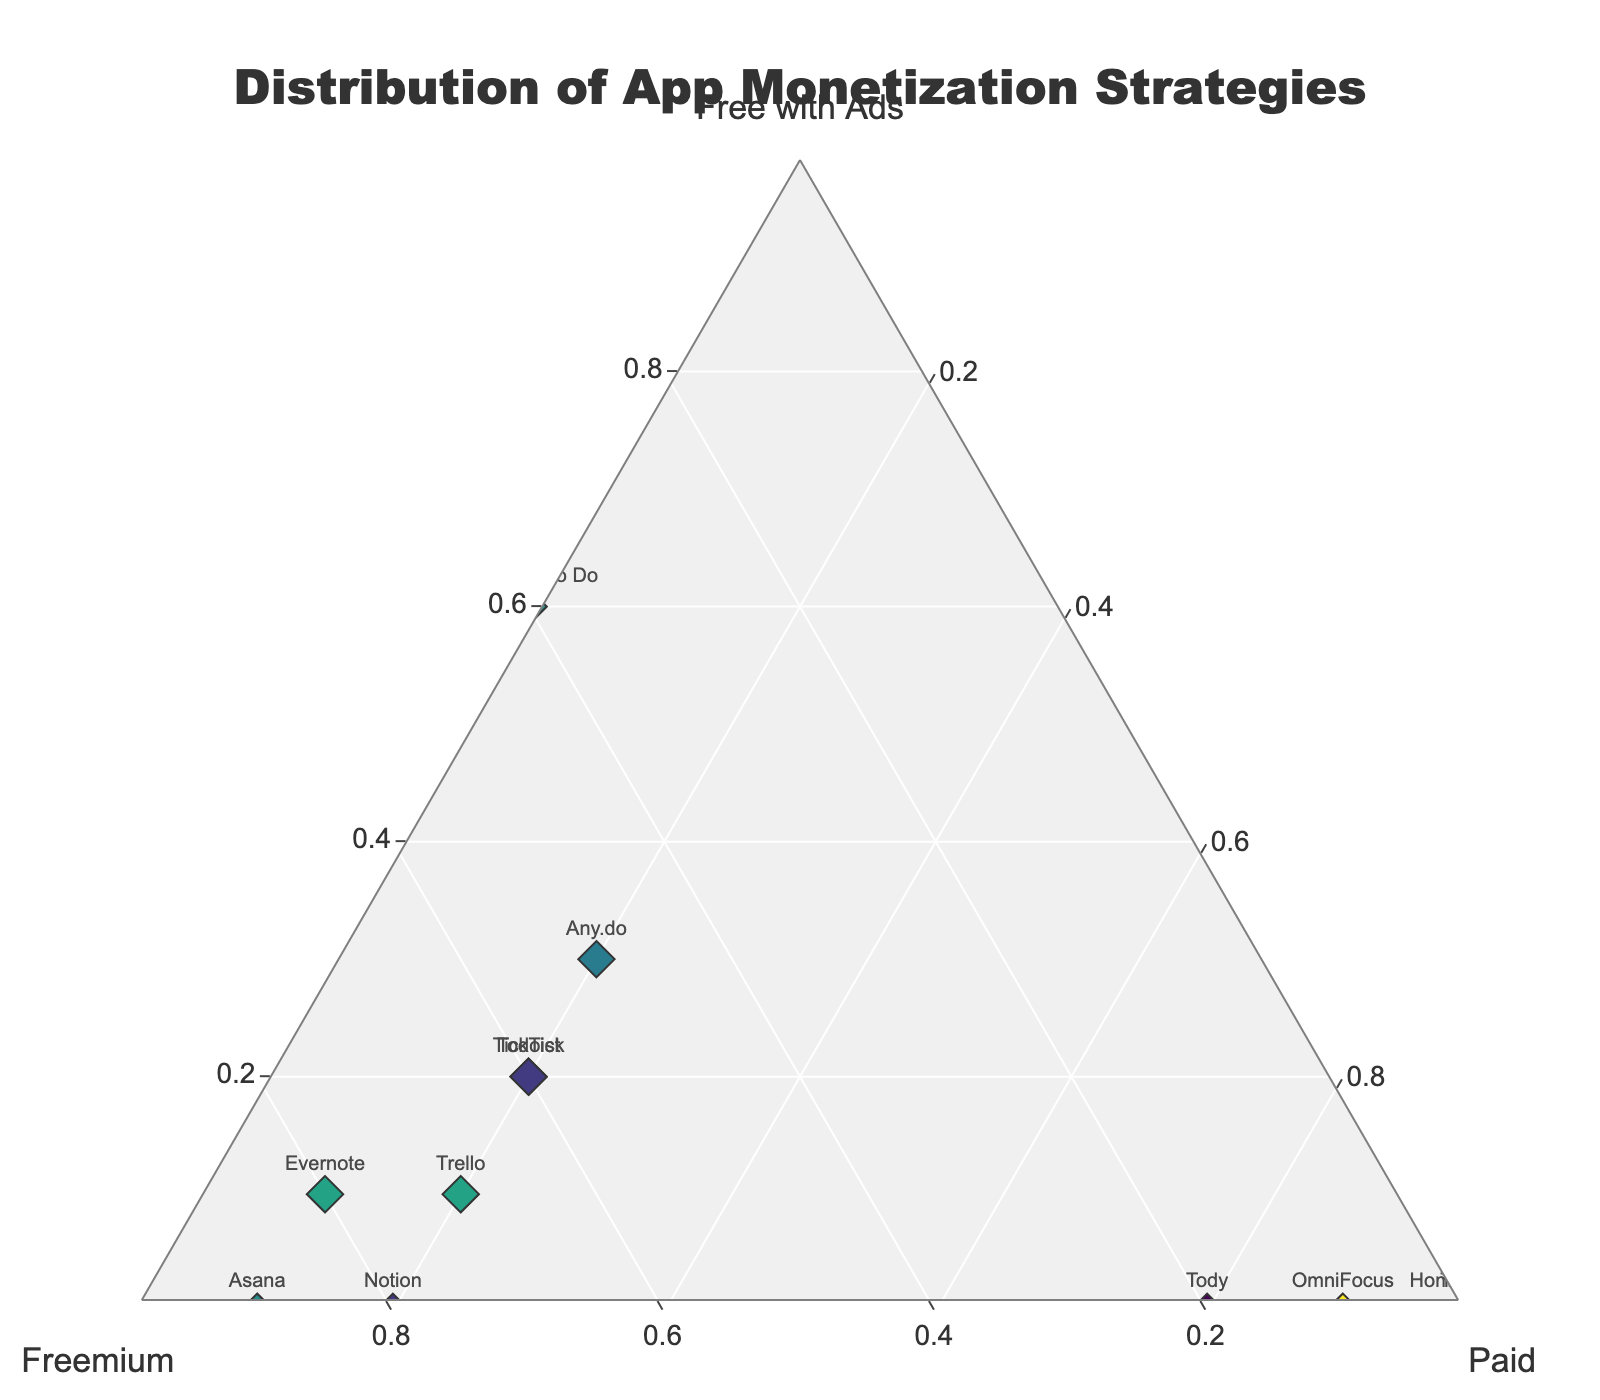What app has the highest percentage of 'Freemium' monetization strategy? Look at the position of each app on the ternary plot. The app that is positioned closest to the 'Freemium' vertex has the highest percentage in that category.
Answer: Asana How many apps use the 'Paid' monetization strategy exclusively? Identify the apps that are positioned exactly along the 'Paid' axis, indicating a 100% use of the 'Paid' strategy.
Answer: Three Which app is positioned exactly at the 'Free with Ads' vertex? Find the app that is positioned at the vertex of the 'Free with Ads' axis, indicating a 100% use of this strategy.
Answer: Google Keep Compare the 'Free with Ads' percentage of Evernote and Microsoft To Do. Which app has a higher percentage? Look at the positions of Evernote and Microsoft To Do on the ternary plot. Check which app is closer to the 'Free with Ads' vertex.
Answer: Microsoft To Do What's the common monetization strategy shared by both OmniFocus and Tody? Identify the apps on the plot and observe which axis or area they both reside in.
Answer: Paid Which app is closest to a balanced use of all three monetization strategies? Look for the app that is positioned nearest to the center of the ternary plot, indicating roughly equal use of all three strategies.
Answer: Todoist How many apps have at least some percentage in each of the three monetization strategies? Identify the apps that are not positioned along any of the three pure axes (not close to any of the vertices).
Answer: Three Is there any app that shares the exact same monetization strategy distribution as another app? Look at the positions of all the apps on the ternary plot. See if any two apps are located at the same point.
Answer: No Which app has the lowest percentage for 'Freemium' strategy? Look for the app positioned farthest from the 'Freemium' vertex and closest to the axis opposite to it.
Answer: Google Keep What is the combined percentage of 'Freemium' and 'Paid' for Notion? Find the percentage of 'Freemium' and 'Paid' for Notion from the plot, then sum these percentages together.
Answer: 1.0 